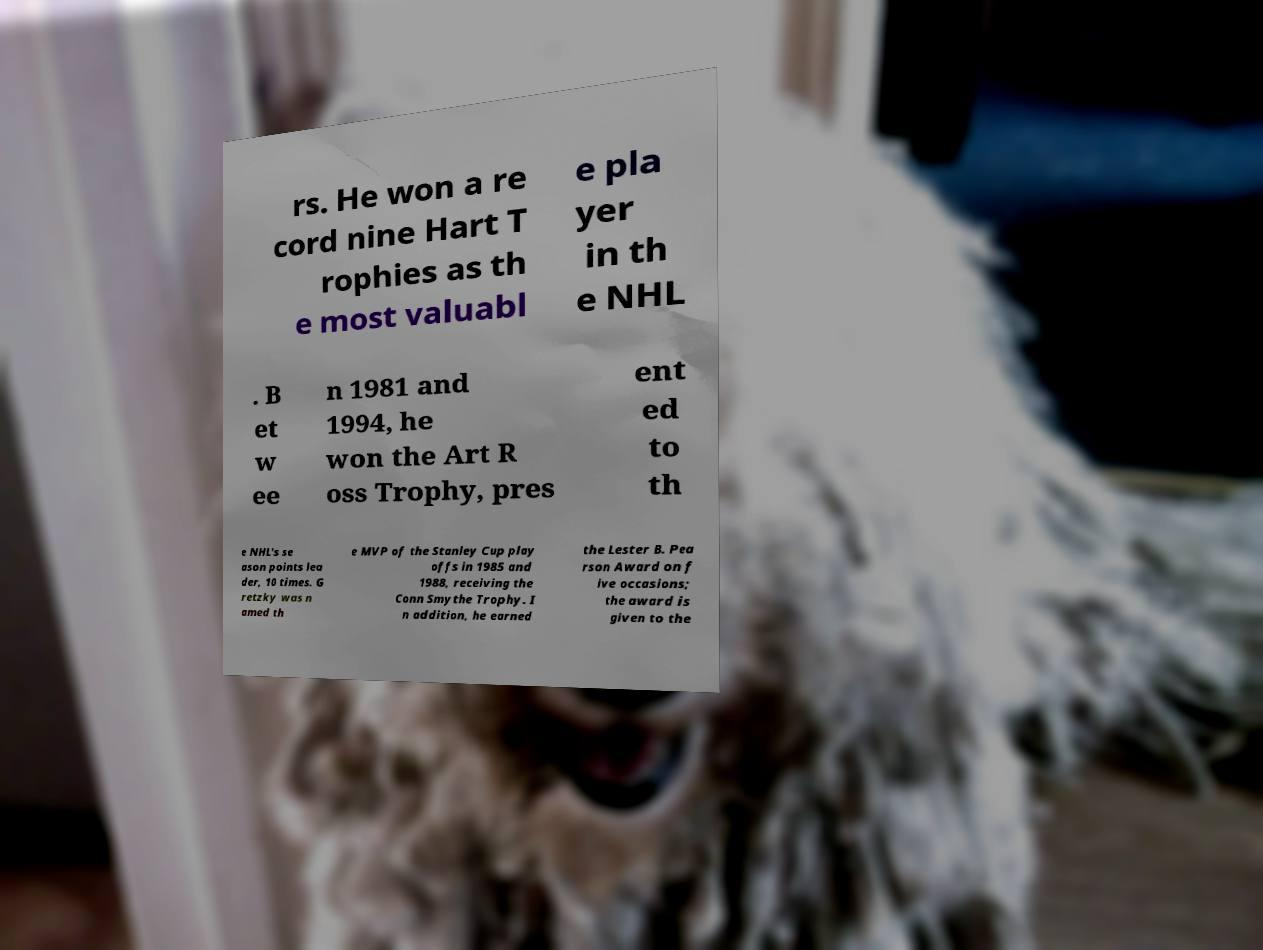Can you accurately transcribe the text from the provided image for me? rs. He won a re cord nine Hart T rophies as th e most valuabl e pla yer in th e NHL . B et w ee n 1981 and 1994, he won the Art R oss Trophy, pres ent ed to th e NHL's se ason points lea der, 10 times. G retzky was n amed th e MVP of the Stanley Cup play offs in 1985 and 1988, receiving the Conn Smythe Trophy. I n addition, he earned the Lester B. Pea rson Award on f ive occasions; the award is given to the 